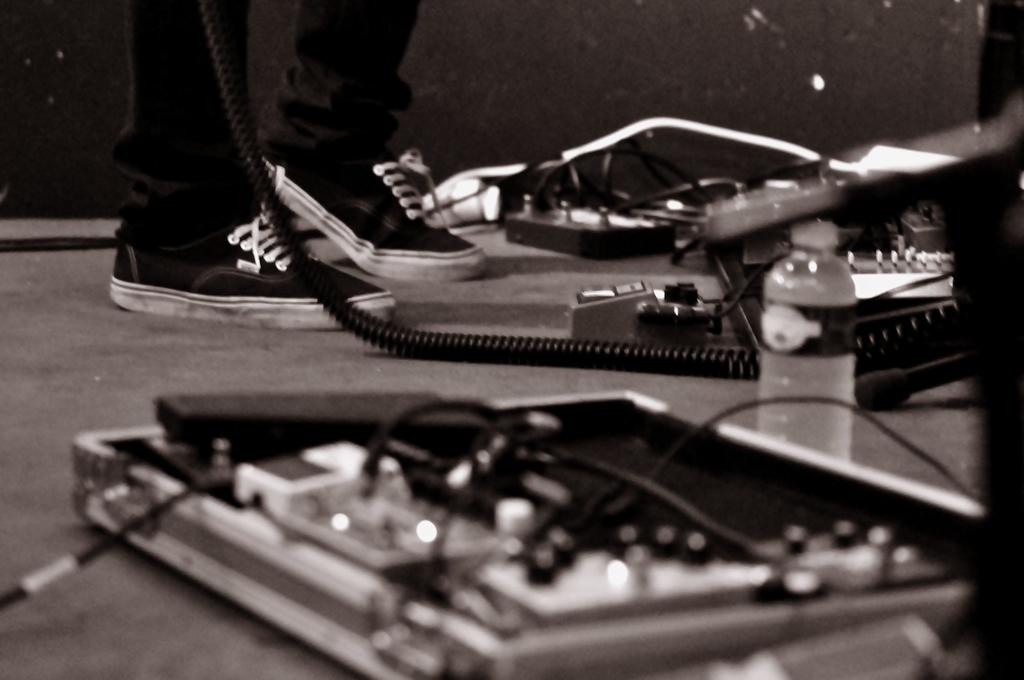What part of a person can be seen in the image? There are legs of a person in the image. What else is visible in the image besides the person's legs? There are objects on a surface in the image. What type of record can be seen in the image? There is no record present in the image. 